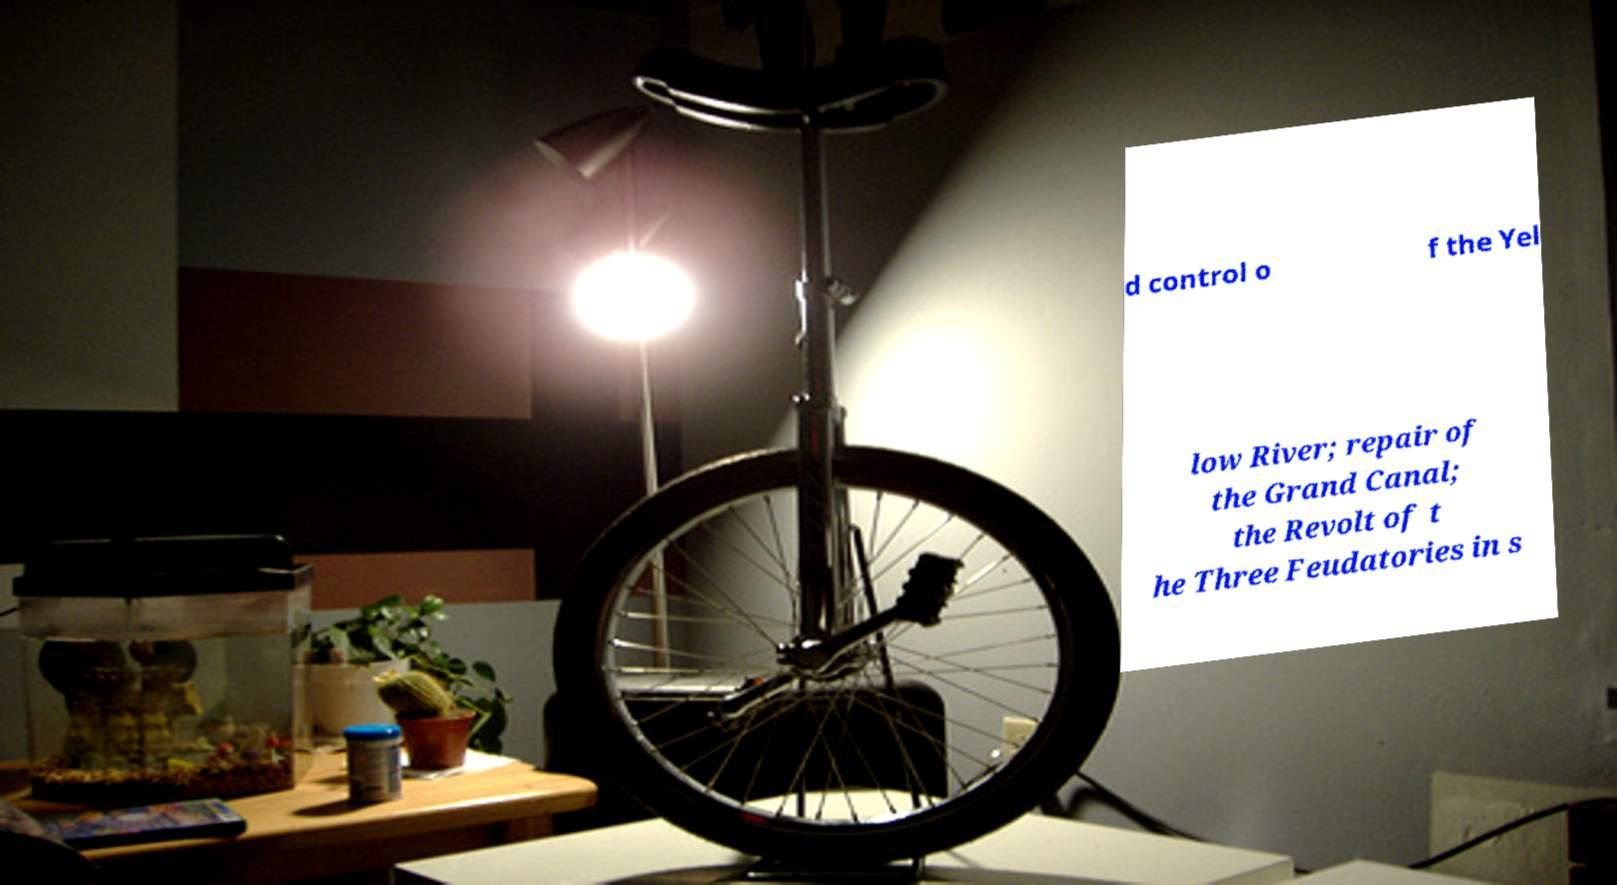Can you read and provide the text displayed in the image?This photo seems to have some interesting text. Can you extract and type it out for me? d control o f the Yel low River; repair of the Grand Canal; the Revolt of t he Three Feudatories in s 